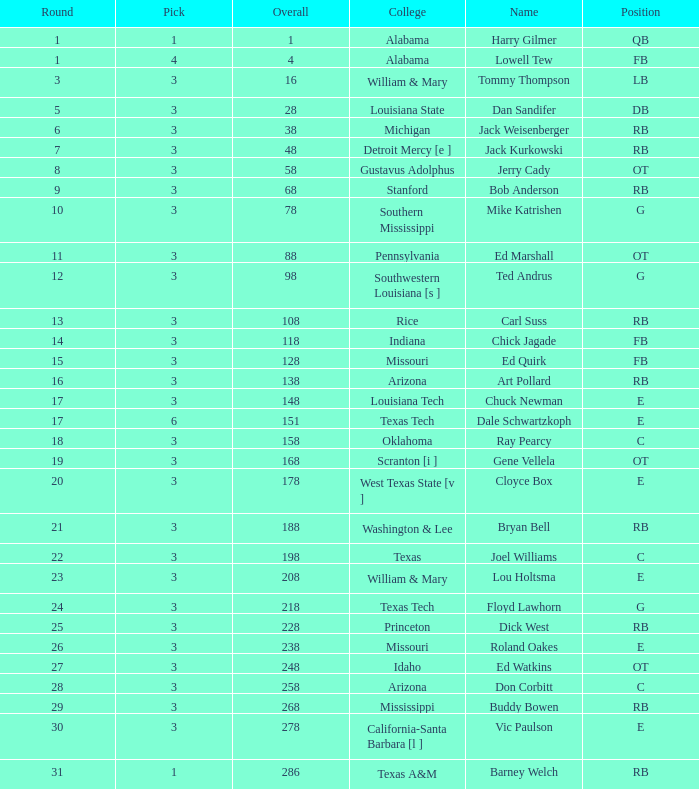Which Overall has a Name of bob anderson, and a Round smaller than 9? None. 